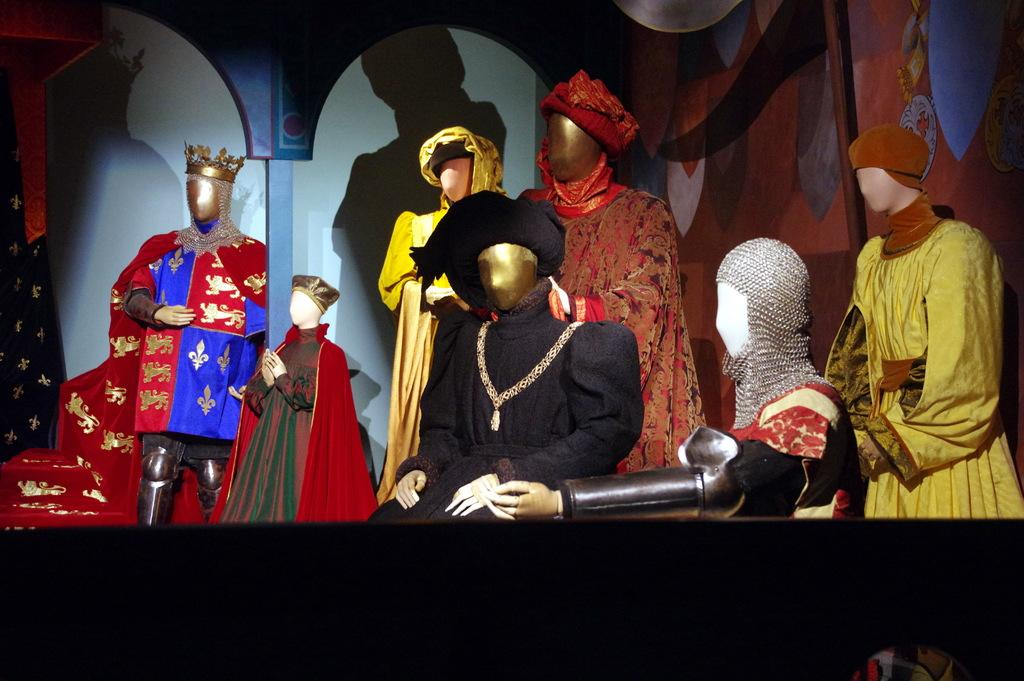What type of figures are present in the image? There are mannequins in the image. What are the mannequins wearing or displaying? There are clothes in the image. What are the poles used for in the image? The poles are likely used for displaying the clothes or mannequins. Can you describe any other objects in the image? There are some objects in the image, but their purpose is not clear. What can be seen in the background of the image? There is a wall in the background of the image. Can you tell me how many vases are on the wall in the image? There are no vases present in the image; it features mannequins, clothes, and poles. What type of baseball equipment can be seen in the image? There is no baseball equipment present in the image. 